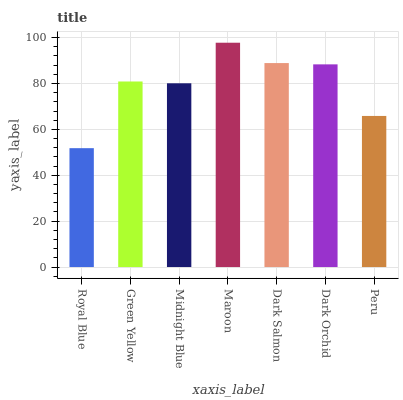Is Green Yellow the minimum?
Answer yes or no. No. Is Green Yellow the maximum?
Answer yes or no. No. Is Green Yellow greater than Royal Blue?
Answer yes or no. Yes. Is Royal Blue less than Green Yellow?
Answer yes or no. Yes. Is Royal Blue greater than Green Yellow?
Answer yes or no. No. Is Green Yellow less than Royal Blue?
Answer yes or no. No. Is Green Yellow the high median?
Answer yes or no. Yes. Is Green Yellow the low median?
Answer yes or no. Yes. Is Midnight Blue the high median?
Answer yes or no. No. Is Dark Salmon the low median?
Answer yes or no. No. 